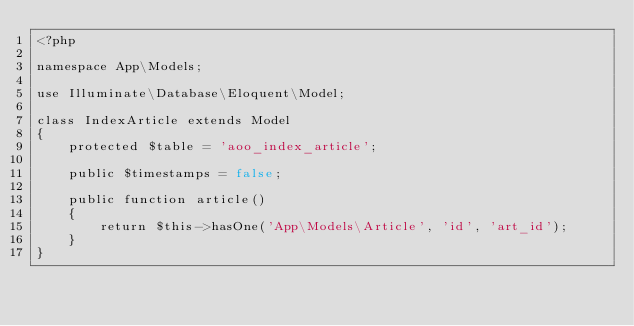<code> <loc_0><loc_0><loc_500><loc_500><_PHP_><?php

namespace App\Models;

use Illuminate\Database\Eloquent\Model;

class IndexArticle extends Model
{
    protected $table = 'aoo_index_article';

    public $timestamps = false;

    public function article()
    {
        return $this->hasOne('App\Models\Article', 'id', 'art_id');
    }
}
</code> 